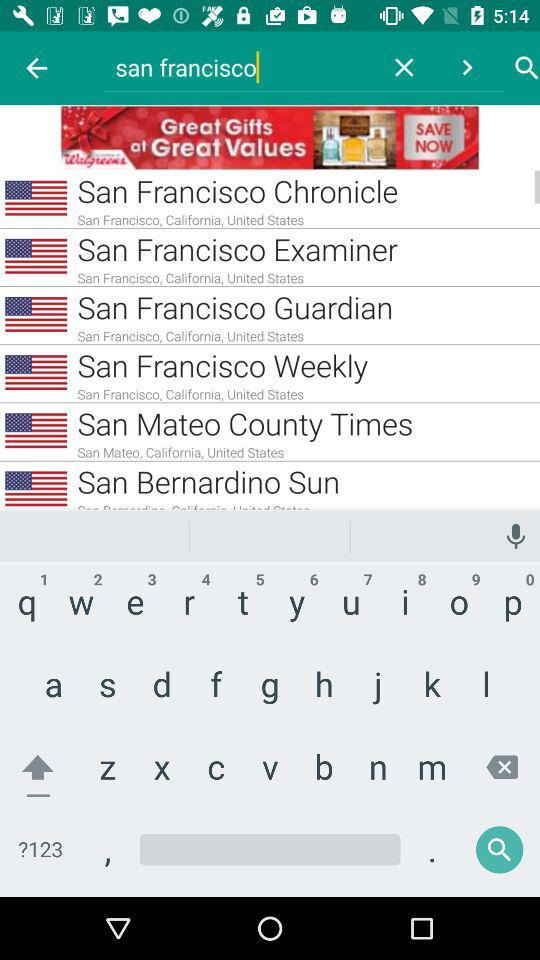Which text is entered in the input field? The text that is entered in the input field is "san francisco". 